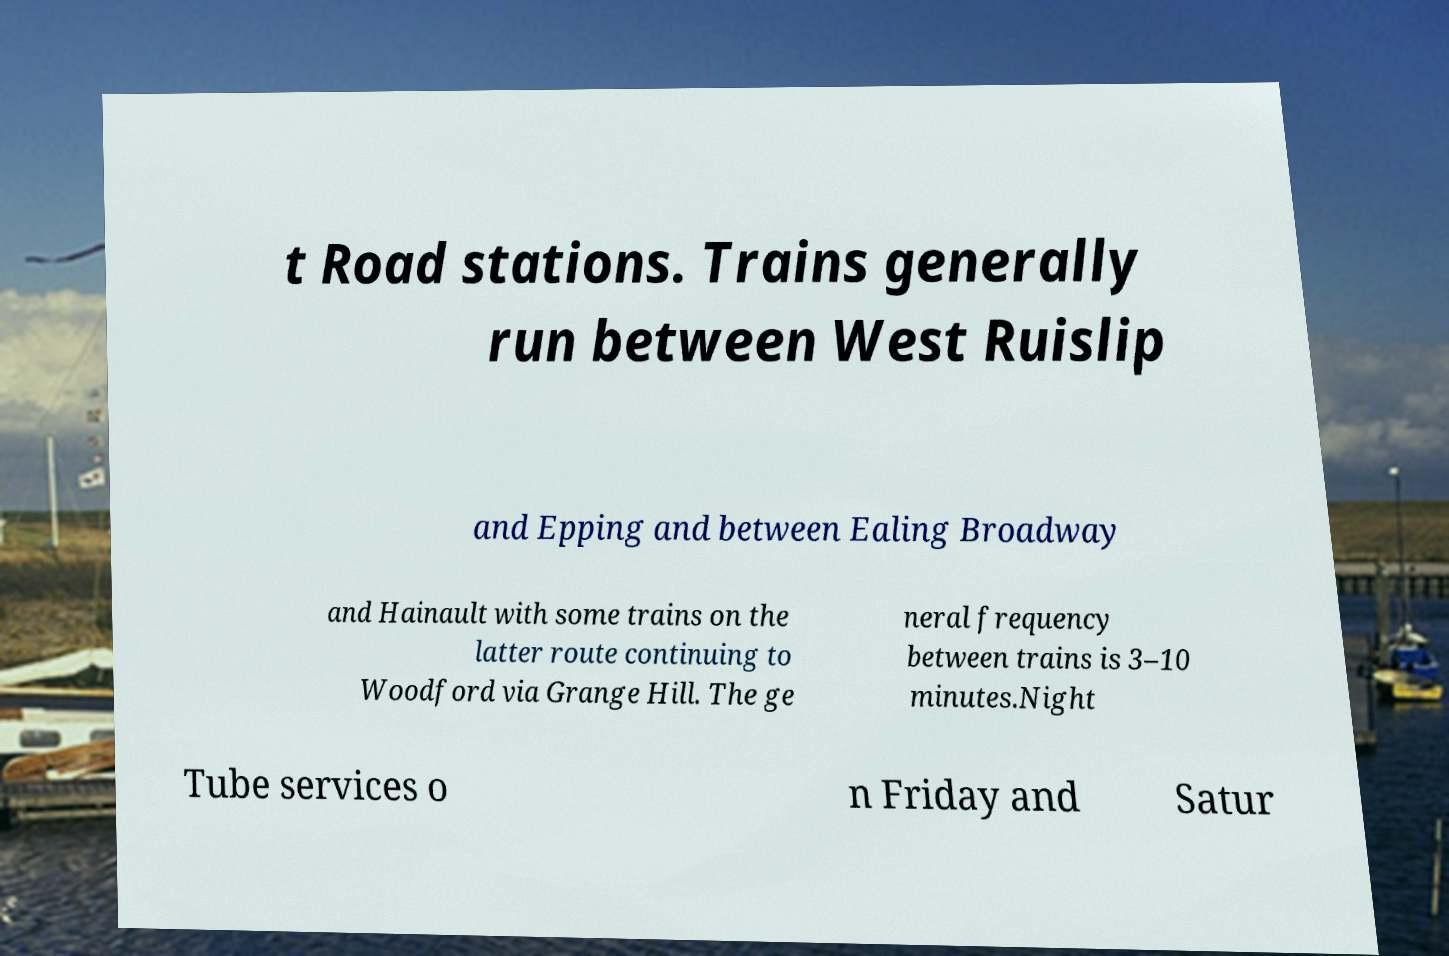What messages or text are displayed in this image? I need them in a readable, typed format. t Road stations. Trains generally run between West Ruislip and Epping and between Ealing Broadway and Hainault with some trains on the latter route continuing to Woodford via Grange Hill. The ge neral frequency between trains is 3–10 minutes.Night Tube services o n Friday and Satur 